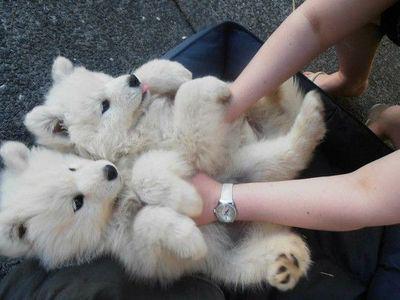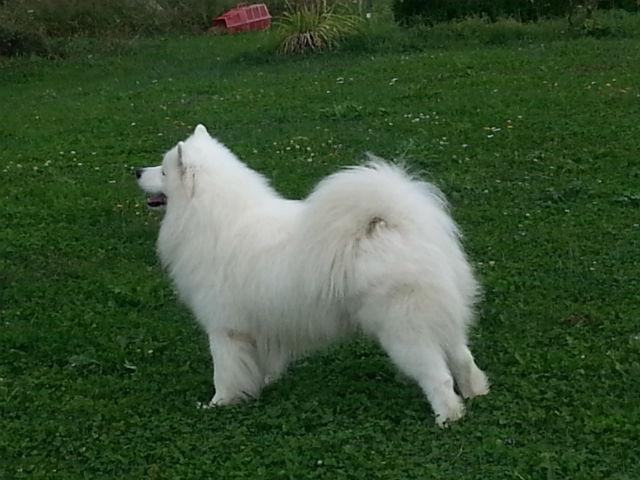The first image is the image on the left, the second image is the image on the right. Examine the images to the left and right. Is the description "We have no more than three dogs in total." accurate? Answer yes or no. Yes. The first image is the image on the left, the second image is the image on the right. For the images shown, is this caption "There are no more than three dogs and one of them has it's mouth open." true? Answer yes or no. Yes. 